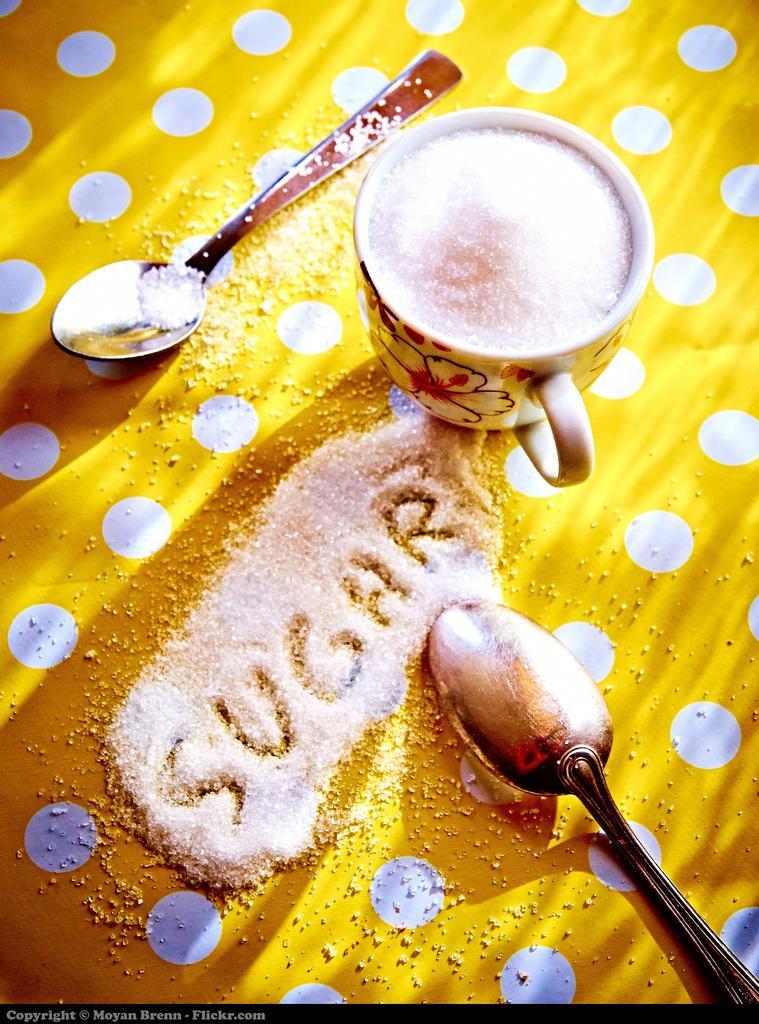How would you summarize this image in a sentence or two? This image consists of two spoons and a cup of sugar. At the bottom, there is a cloth. On which we can see the sugar crystals. 